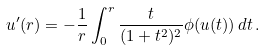Convert formula to latex. <formula><loc_0><loc_0><loc_500><loc_500>u ^ { \prime } ( r ) = - \frac { 1 } { r } \int _ { 0 } ^ { r } \frac { t } { ( 1 + t ^ { 2 } ) ^ { 2 } } \phi ( u ( t ) ) \, d t \, .</formula> 